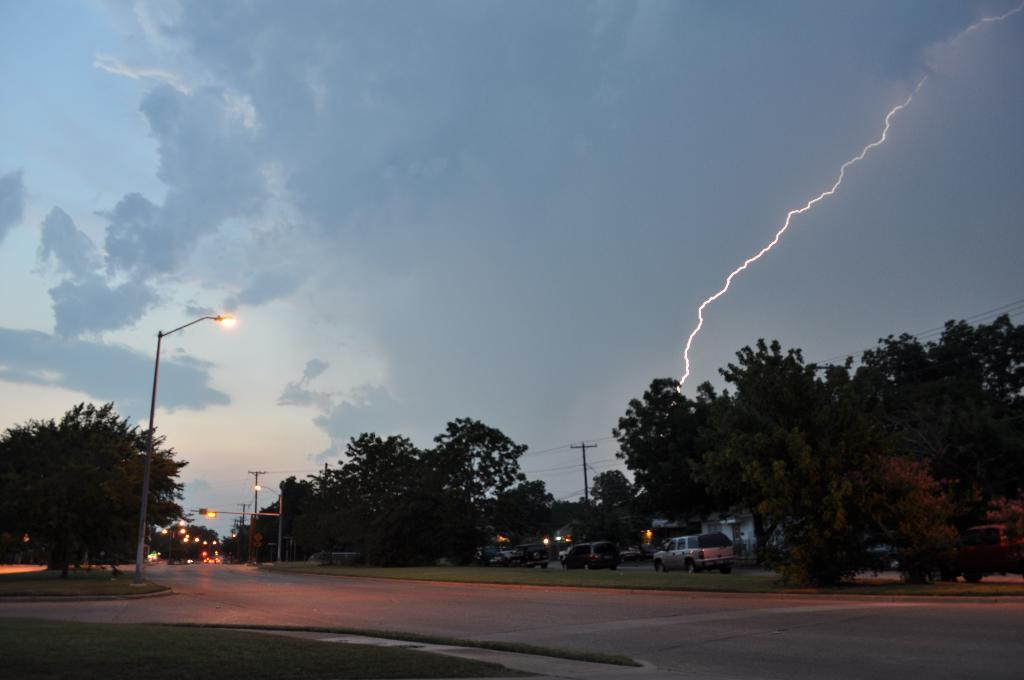What can be seen on the road in the image? There are vehicles on the road in the image. What type of vegetation is visible in the image? Trees and grass are present in the image. What structures can be seen in the image? Light poles and a current pole are in the image. What is the condition of the sky in the image? The sky is cloudy and there is a thunderstorm in the image. Where is the cannon located in the image? There is no cannon present in the image. What type of development is taking place in the image? The image does not depict any development; it shows vehicles on the road, trees, grass, light poles, a current pole, and a cloudy sky with a thunderstorm. Can you describe the door in the image? There is no door present in the image. 